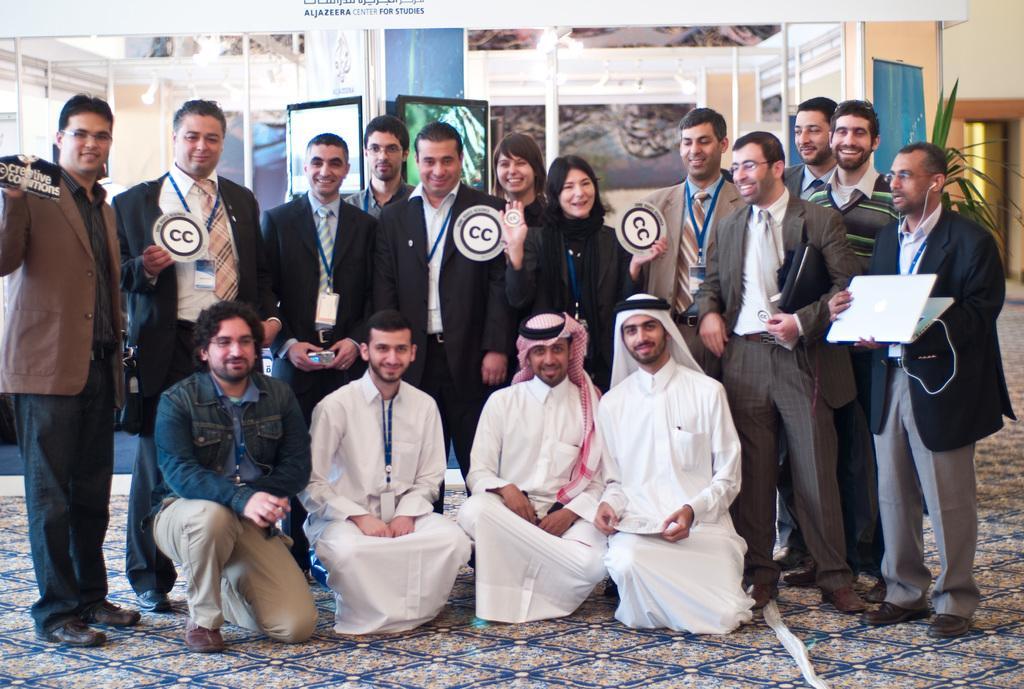Describe this image in one or two sentences. In this picture we can see a group of people, laptop, plant, walls, screens, poles, some objects and these people are smiling. 